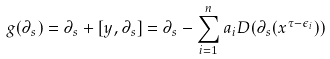Convert formula to latex. <formula><loc_0><loc_0><loc_500><loc_500>g ( \partial _ { s } ) = \partial _ { s } + [ y , \partial _ { s } ] = \partial _ { s } - \sum _ { i = 1 } ^ { n } a _ { i } D ( \partial _ { s } ( x ^ { \tau - \epsilon _ { i } } ) )</formula> 